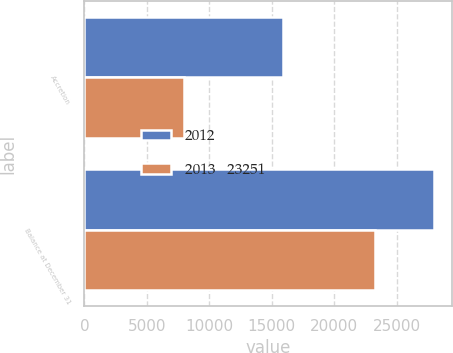Convert chart to OTSL. <chart><loc_0><loc_0><loc_500><loc_500><stacked_bar_chart><ecel><fcel>Accretion<fcel>Balance at December 31<nl><fcel>2012<fcel>15931<fcel>27995<nl><fcel>2013   23251<fcel>7960<fcel>23251<nl></chart> 